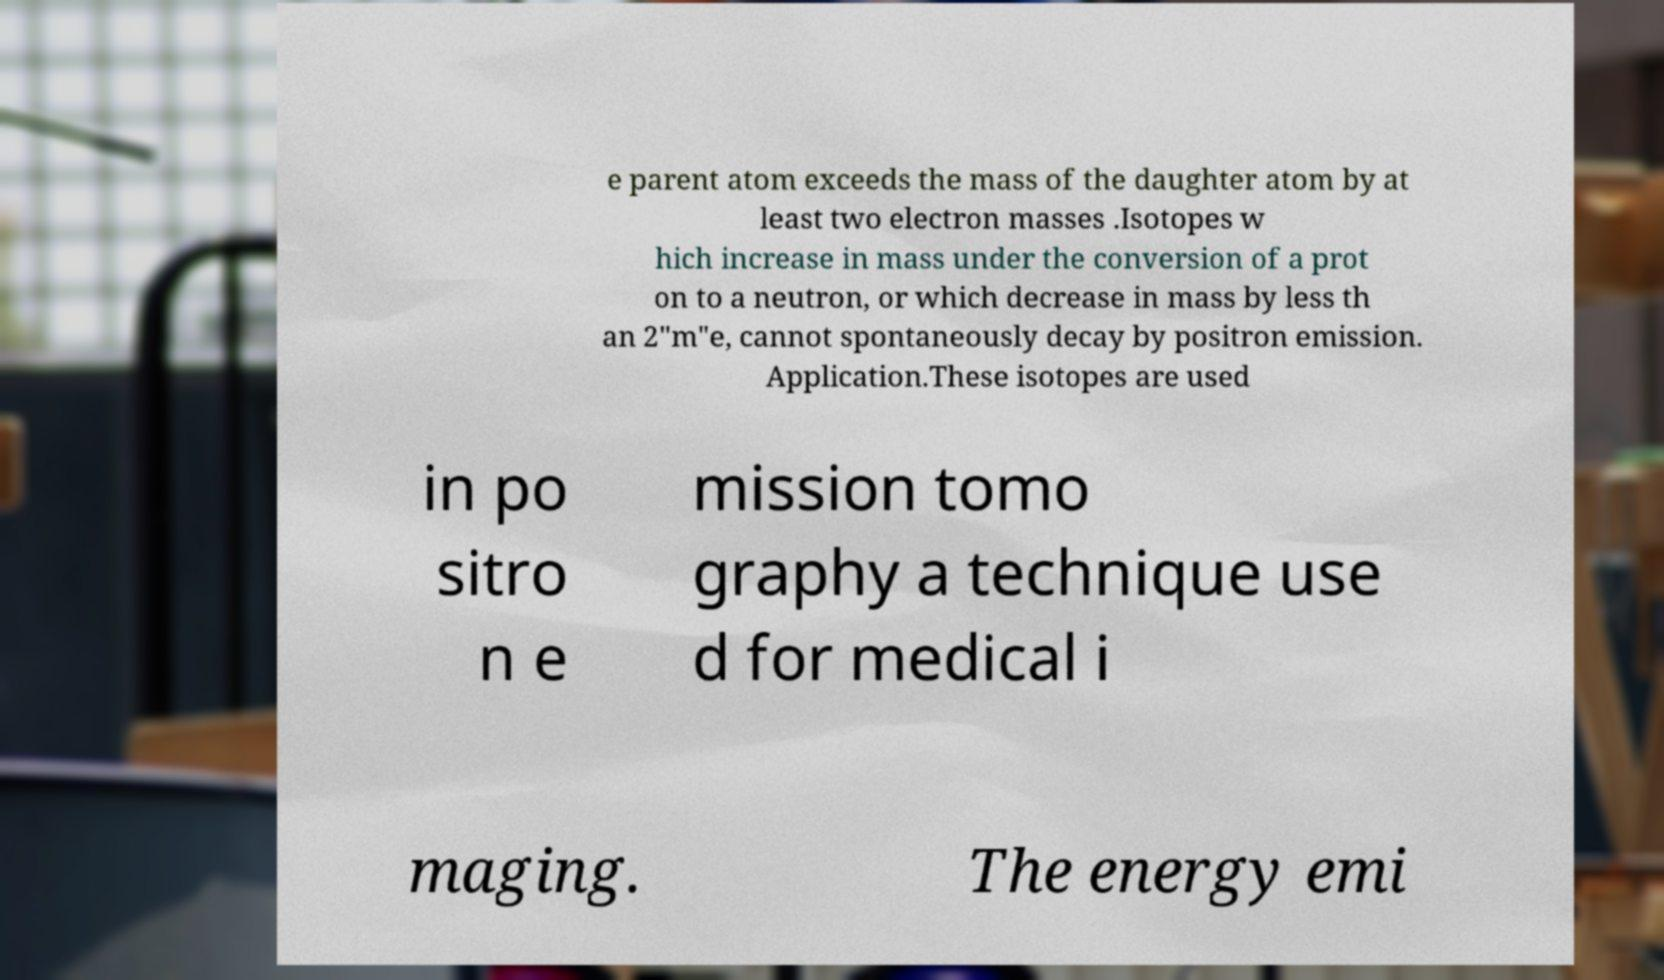I need the written content from this picture converted into text. Can you do that? e parent atom exceeds the mass of the daughter atom by at least two electron masses .Isotopes w hich increase in mass under the conversion of a prot on to a neutron, or which decrease in mass by less th an 2"m"e, cannot spontaneously decay by positron emission. Application.These isotopes are used in po sitro n e mission tomo graphy a technique use d for medical i maging. The energy emi 